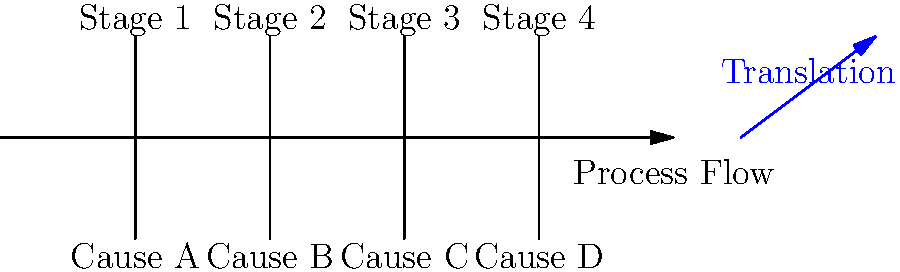In a Lean Six Sigma project, you've created a fishbone diagram to identify root causes of process inefficiencies. You now need to align these causes with specific process stages. Using the concept of translation in transformational geometry, how would you move the root causes (A, B, C, D) upward to align with their corresponding process stages (1, 2, 3, 4)? What is the translation vector that would achieve this alignment? To align the root causes with their corresponding process stages using translation, we need to follow these steps:

1. Identify the current position of the root causes:
   Cause A: (40, -30)
   Cause B: (80, -30)
   Cause C: (120, -30)
   Cause D: (160, -30)

2. Identify the target position for each cause (aligned with stages):
   Stage 1: (40, 30)
   Stage 2: (80, 30)
   Stage 3: (120, 30)
   Stage 4: (160, 30)

3. Calculate the translation vector:
   - The x-coordinate remains the same for each cause
   - The y-coordinate needs to move from -30 to 30
   - The change in y is: 30 - (-30) = 60

4. Express the translation vector:
   The translation vector is $\vec{v} = (0, 60)$

5. Verify the translation:
   - Cause A: (40, -30) + (0, 60) = (40, 30)
   - Cause B: (80, -30) + (0, 60) = (80, 30)
   - Cause C: (120, -30) + (0, 60) = (120, 30)
   - Cause D: (160, -30) + (0, 60) = (160, 30)

This translation vector $(0, 60)$ will move all root causes upward by 60 units, aligning them with their corresponding process stages.
Answer: $(0, 60)$ 